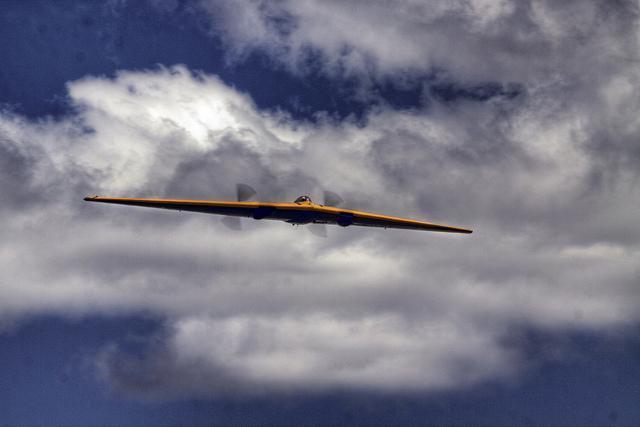How many people are calling on phone?
Give a very brief answer. 0. 